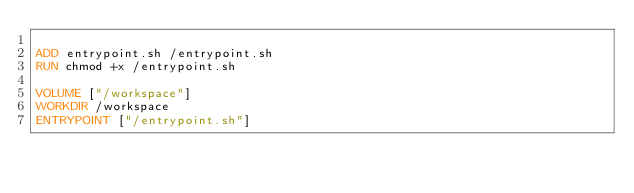<code> <loc_0><loc_0><loc_500><loc_500><_Dockerfile_>
ADD entrypoint.sh /entrypoint.sh
RUN chmod +x /entrypoint.sh

VOLUME ["/workspace"]
WORKDIR /workspace
ENTRYPOINT ["/entrypoint.sh"]
</code> 